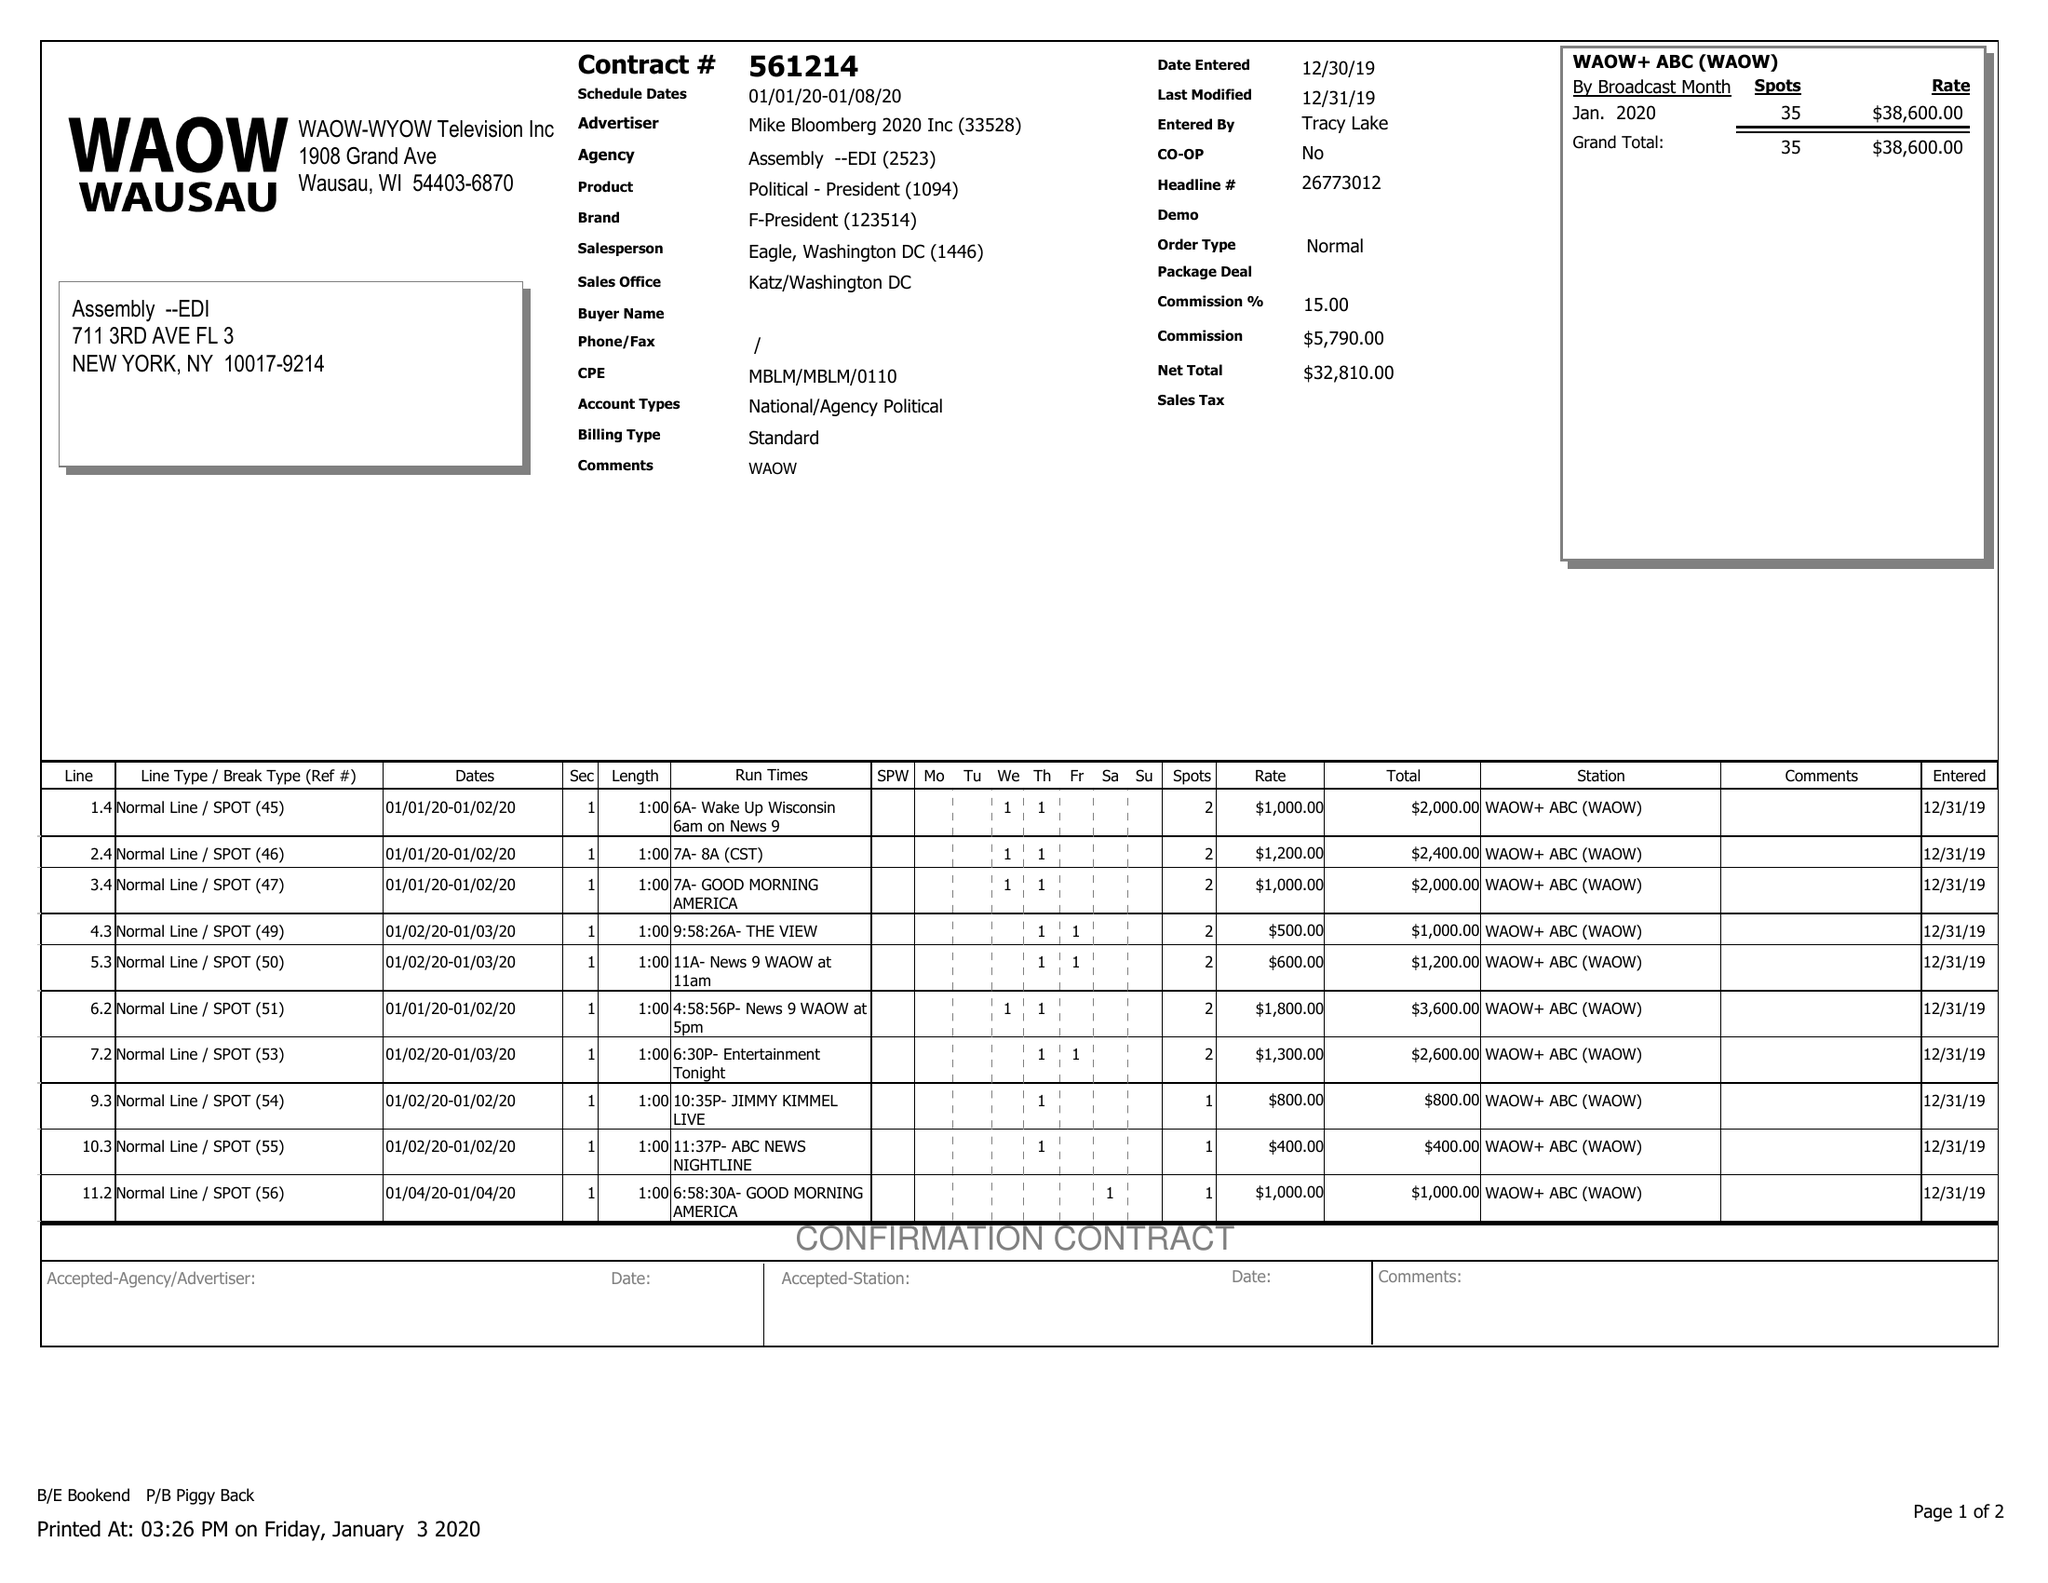What is the value for the contract_num?
Answer the question using a single word or phrase. 561214 